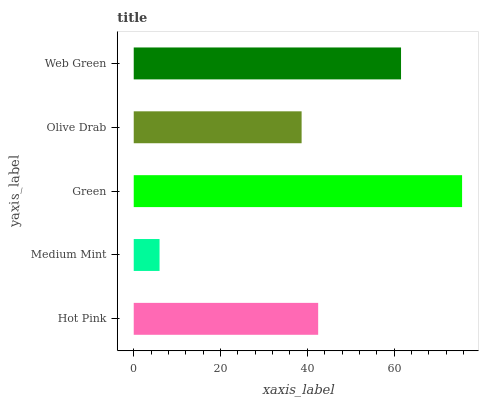Is Medium Mint the minimum?
Answer yes or no. Yes. Is Green the maximum?
Answer yes or no. Yes. Is Green the minimum?
Answer yes or no. No. Is Medium Mint the maximum?
Answer yes or no. No. Is Green greater than Medium Mint?
Answer yes or no. Yes. Is Medium Mint less than Green?
Answer yes or no. Yes. Is Medium Mint greater than Green?
Answer yes or no. No. Is Green less than Medium Mint?
Answer yes or no. No. Is Hot Pink the high median?
Answer yes or no. Yes. Is Hot Pink the low median?
Answer yes or no. Yes. Is Medium Mint the high median?
Answer yes or no. No. Is Green the low median?
Answer yes or no. No. 